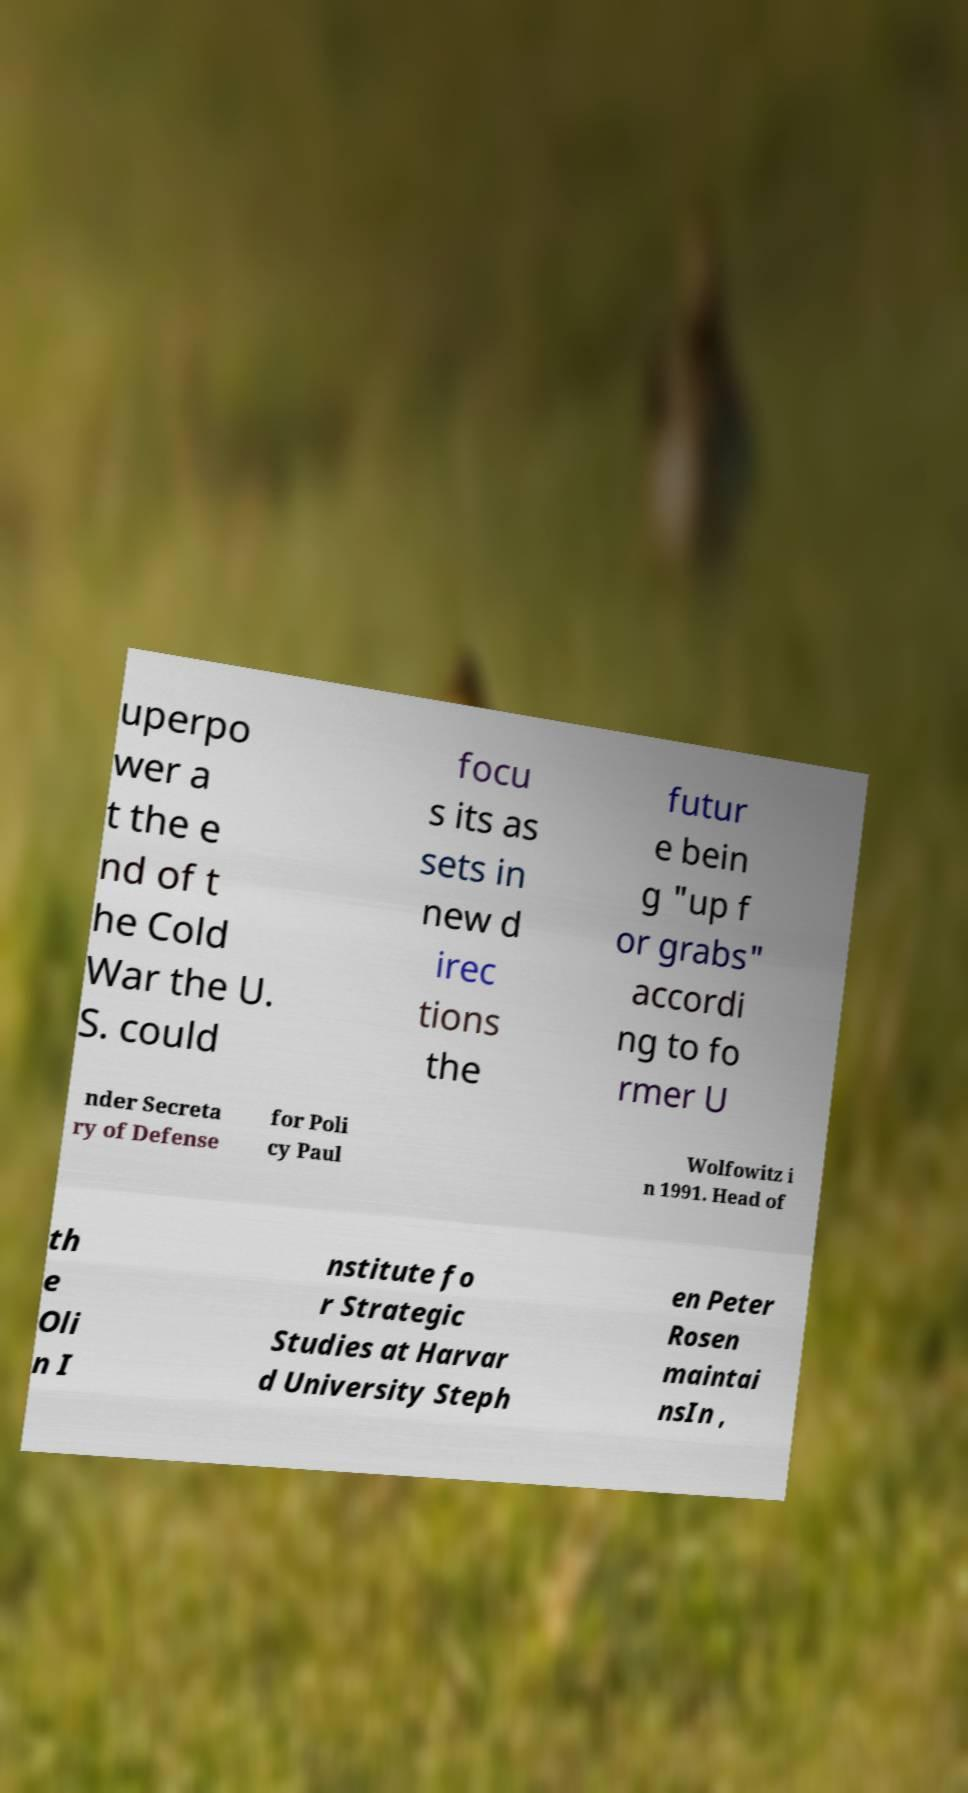Could you assist in decoding the text presented in this image and type it out clearly? uperpo wer a t the e nd of t he Cold War the U. S. could focu s its as sets in new d irec tions the futur e bein g "up f or grabs" accordi ng to fo rmer U nder Secreta ry of Defense for Poli cy Paul Wolfowitz i n 1991. Head of th e Oli n I nstitute fo r Strategic Studies at Harvar d University Steph en Peter Rosen maintai nsIn , 